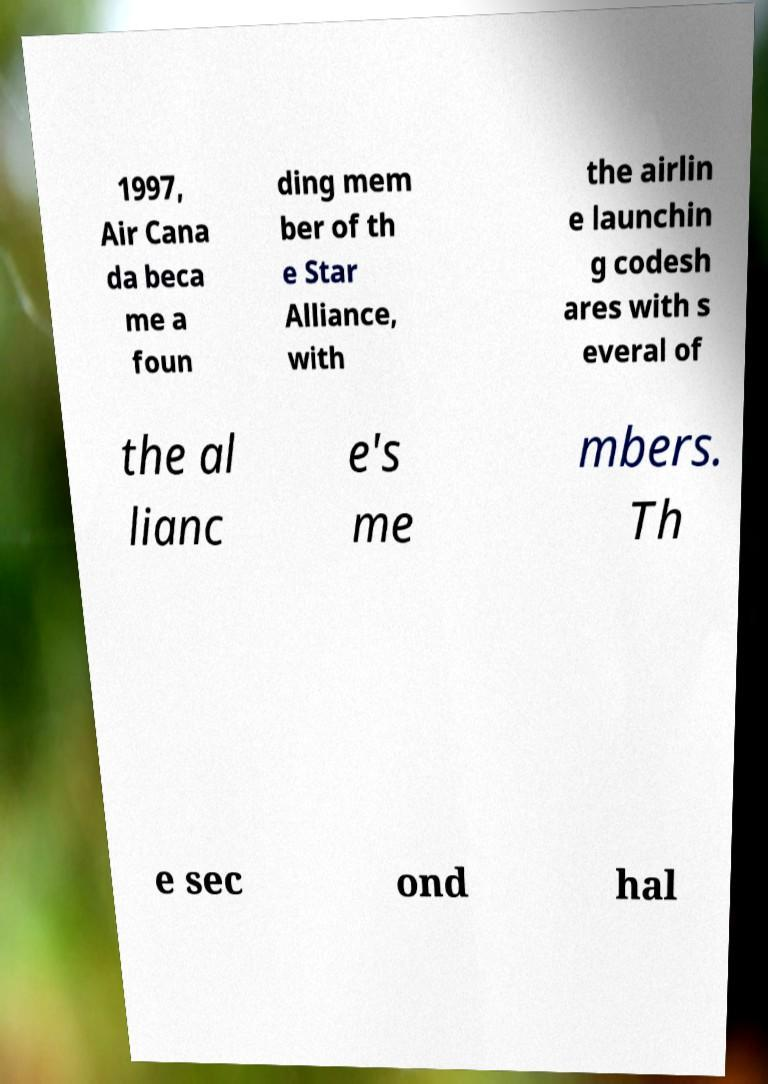What messages or text are displayed in this image? I need them in a readable, typed format. 1997, Air Cana da beca me a foun ding mem ber of th e Star Alliance, with the airlin e launchin g codesh ares with s everal of the al lianc e's me mbers. Th e sec ond hal 